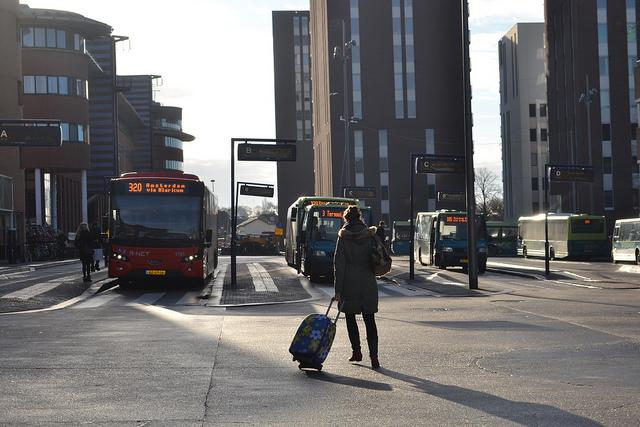What activity is the woman participating in? Please explain your reasoning. travel. The woman is traveling with her luggage. 